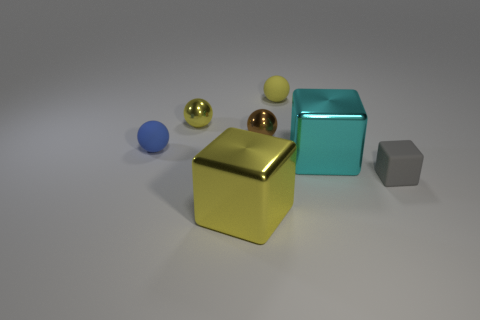There is a blue thing that is the same shape as the brown metallic object; what is its size?
Your answer should be very brief. Small. There is a small brown thing that is behind the big metallic object on the left side of the large cyan cube; are there any tiny blue objects that are left of it?
Provide a short and direct response. Yes. Is there any other thing that has the same size as the yellow rubber thing?
Offer a very short reply. Yes. There is a brown metal object; does it have the same shape as the yellow metal object that is in front of the large cyan thing?
Offer a terse response. No. There is a large thing behind the big metal object that is in front of the large metal block that is right of the big yellow metallic object; what is its color?
Your answer should be compact. Cyan. How many objects are either matte balls that are in front of the yellow rubber sphere or matte balls left of the small brown thing?
Your response must be concise. 1. Do the large object in front of the gray object and the blue thing have the same shape?
Keep it short and to the point. No. Is the number of tiny rubber spheres that are in front of the brown metallic thing less than the number of cyan rubber cylinders?
Offer a terse response. No. Are there any tiny blue things that have the same material as the large cyan cube?
Your answer should be compact. No. There is a brown thing that is the same size as the yellow matte ball; what material is it?
Keep it short and to the point. Metal. 